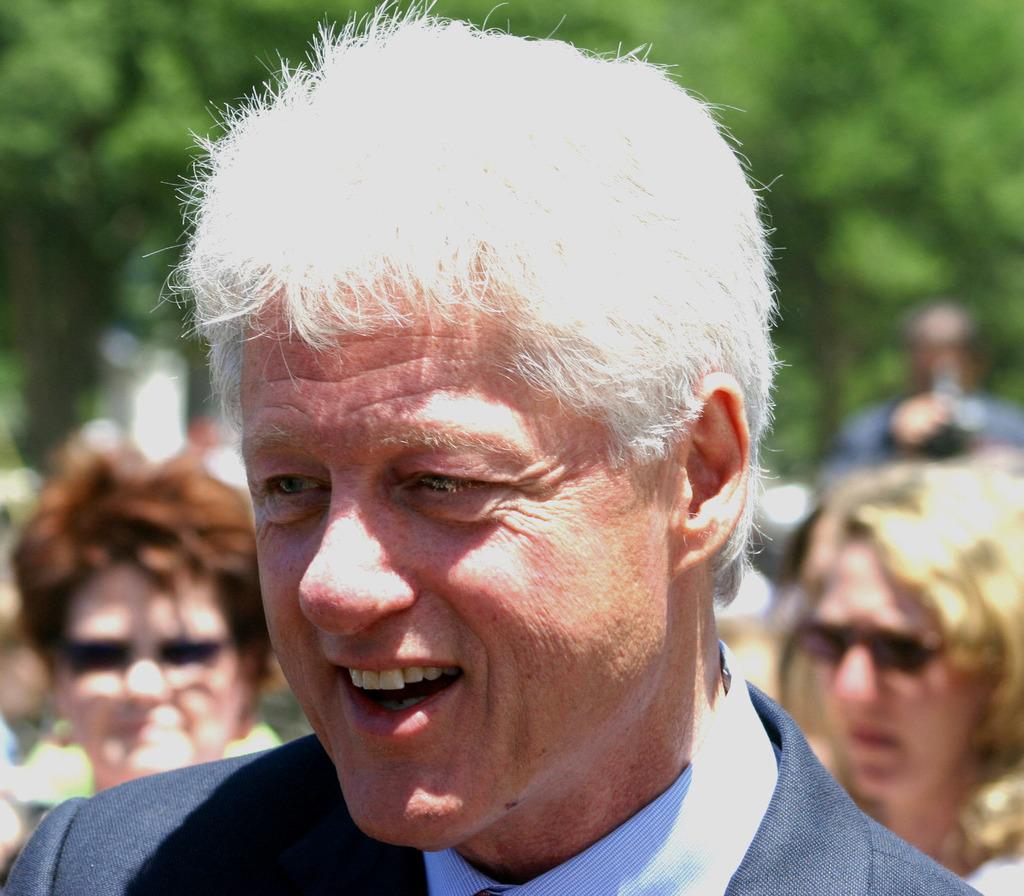Could you give a brief overview of what you see in this image? This picture consists of a group of people on the road and trees in the background. This image taken, maybe during a day. 